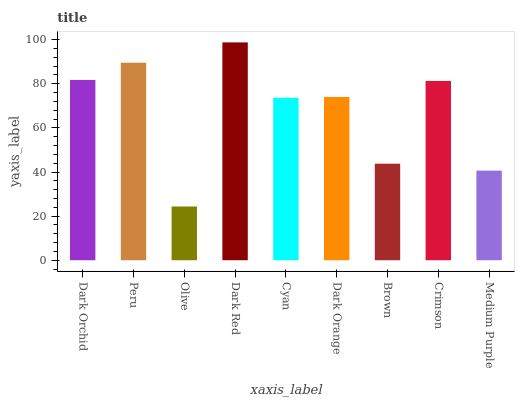Is Olive the minimum?
Answer yes or no. Yes. Is Dark Red the maximum?
Answer yes or no. Yes. Is Peru the minimum?
Answer yes or no. No. Is Peru the maximum?
Answer yes or no. No. Is Peru greater than Dark Orchid?
Answer yes or no. Yes. Is Dark Orchid less than Peru?
Answer yes or no. Yes. Is Dark Orchid greater than Peru?
Answer yes or no. No. Is Peru less than Dark Orchid?
Answer yes or no. No. Is Dark Orange the high median?
Answer yes or no. Yes. Is Dark Orange the low median?
Answer yes or no. Yes. Is Dark Orchid the high median?
Answer yes or no. No. Is Crimson the low median?
Answer yes or no. No. 